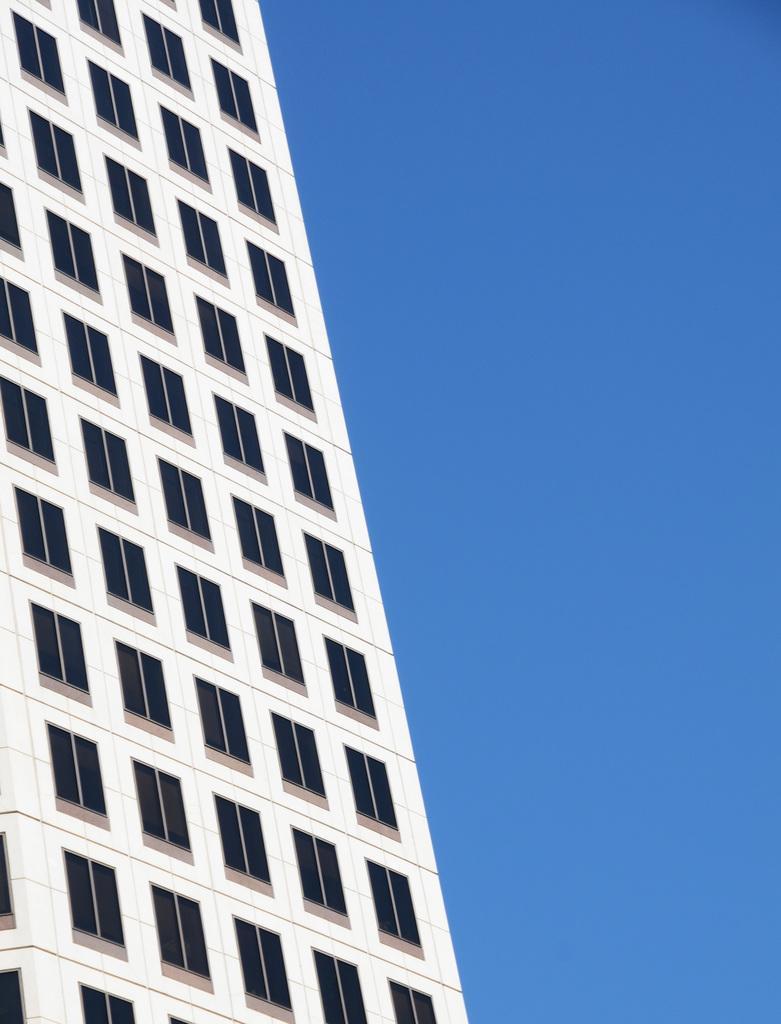In one or two sentences, can you explain what this image depicts? On the left side, we see a building in white color. It has many windows. On the right side, we see the sky, which is blue in color. 